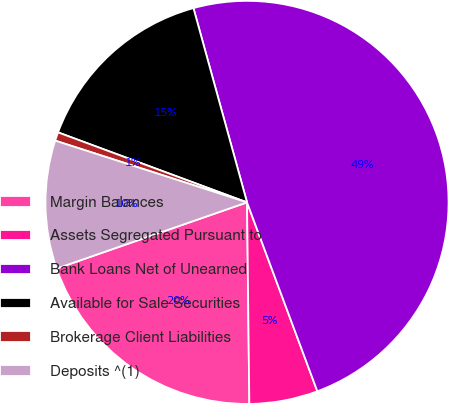Convert chart. <chart><loc_0><loc_0><loc_500><loc_500><pie_chart><fcel>Margin Balances<fcel>Assets Segregated Pursuant to<fcel>Bank Loans Net of Unearned<fcel>Available for Sale Securities<fcel>Brokerage Client Liabilities<fcel>Deposits ^(1)<nl><fcel>19.86%<fcel>5.49%<fcel>48.61%<fcel>15.07%<fcel>0.69%<fcel>10.28%<nl></chart> 